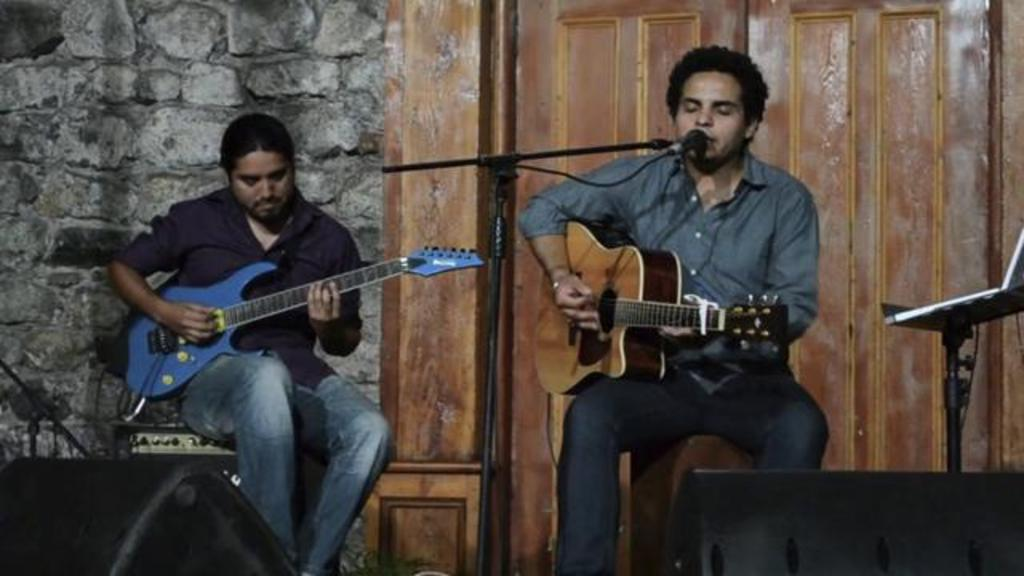How many people are in the image? There are two persons in the image. What are the persons doing in the image? Both persons are sitting and playing guitars. Is one of the persons singing? Yes, one person is singing through a mic. What can be seen in the background of the image? There is a wall and a wooden door in the background of the image. What type of advice can be heard from the person singing in the image? There is no indication in the image that the person singing is giving advice, so it cannot be determined from the picture. 